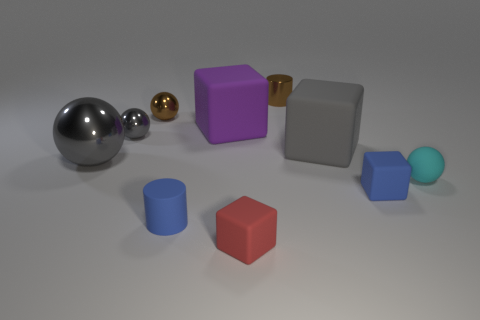There is a cylinder that is right of the blue cylinder; does it have the same color as the metallic sphere behind the big purple block?
Make the answer very short. Yes. How many objects have the same color as the metallic cylinder?
Your answer should be very brief. 1. Are there any brown spheres made of the same material as the small gray object?
Make the answer very short. Yes. Are there more purple rubber things right of the small rubber cylinder than brown cylinders that are right of the cyan rubber object?
Offer a very short reply. Yes. What size is the purple thing?
Ensure brevity in your answer.  Large. The brown object that is right of the tiny blue cylinder has what shape?
Your response must be concise. Cylinder. Do the large purple object and the red thing have the same shape?
Ensure brevity in your answer.  Yes. Are there the same number of brown metal things behind the purple block and brown things?
Your answer should be very brief. Yes. What is the shape of the purple thing?
Give a very brief answer. Cube. Is there anything else that is the same color as the large shiny ball?
Your answer should be compact. Yes. 